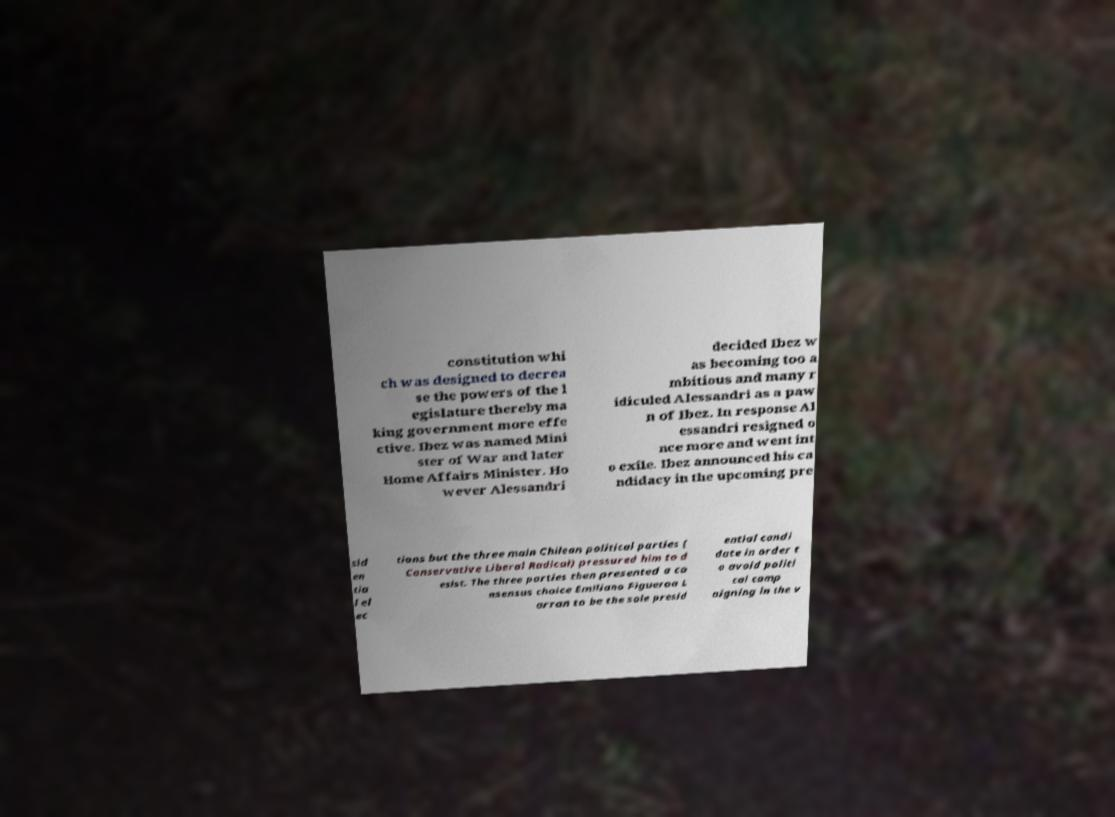What messages or text are displayed in this image? I need them in a readable, typed format. constitution whi ch was designed to decrea se the powers of the l egislature thereby ma king government more effe ctive. Ibez was named Mini ster of War and later Home Affairs Minister. Ho wever Alessandri decided Ibez w as becoming too a mbitious and many r idiculed Alessandri as a paw n of Ibez. In response Al essandri resigned o nce more and went int o exile. Ibez announced his ca ndidacy in the upcoming pre sid en tia l el ec tions but the three main Chilean political parties ( Conservative Liberal Radical) pressured him to d esist. The three parties then presented a co nsensus choice Emiliano Figueroa L arran to be the sole presid ential candi date in order t o avoid politi cal camp aigning in the v 